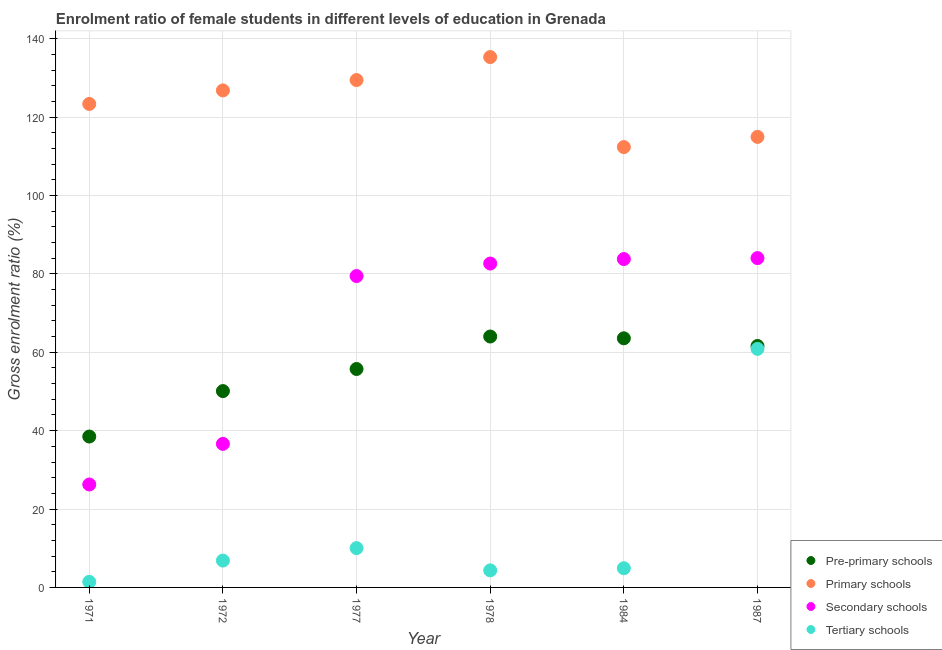Is the number of dotlines equal to the number of legend labels?
Provide a succinct answer. Yes. What is the gross enrolment ratio(male) in tertiary schools in 1972?
Ensure brevity in your answer.  6.85. Across all years, what is the maximum gross enrolment ratio(male) in primary schools?
Offer a terse response. 135.32. Across all years, what is the minimum gross enrolment ratio(male) in primary schools?
Provide a short and direct response. 112.36. In which year was the gross enrolment ratio(male) in pre-primary schools maximum?
Give a very brief answer. 1978. What is the total gross enrolment ratio(male) in secondary schools in the graph?
Ensure brevity in your answer.  392.79. What is the difference between the gross enrolment ratio(male) in pre-primary schools in 1971 and that in 1977?
Ensure brevity in your answer.  -17.23. What is the difference between the gross enrolment ratio(male) in pre-primary schools in 1972 and the gross enrolment ratio(male) in tertiary schools in 1978?
Give a very brief answer. 45.75. What is the average gross enrolment ratio(male) in secondary schools per year?
Provide a short and direct response. 65.46. In the year 1977, what is the difference between the gross enrolment ratio(male) in pre-primary schools and gross enrolment ratio(male) in tertiary schools?
Your answer should be very brief. 45.7. What is the ratio of the gross enrolment ratio(male) in secondary schools in 1978 to that in 1984?
Your answer should be very brief. 0.99. Is the gross enrolment ratio(male) in secondary schools in 1977 less than that in 1978?
Provide a succinct answer. Yes. Is the difference between the gross enrolment ratio(male) in tertiary schools in 1978 and 1984 greater than the difference between the gross enrolment ratio(male) in pre-primary schools in 1978 and 1984?
Keep it short and to the point. No. What is the difference between the highest and the second highest gross enrolment ratio(male) in primary schools?
Your answer should be very brief. 5.87. What is the difference between the highest and the lowest gross enrolment ratio(male) in tertiary schools?
Make the answer very short. 59.44. Is it the case that in every year, the sum of the gross enrolment ratio(male) in secondary schools and gross enrolment ratio(male) in tertiary schools is greater than the sum of gross enrolment ratio(male) in pre-primary schools and gross enrolment ratio(male) in primary schools?
Your answer should be compact. No. Does the gross enrolment ratio(male) in tertiary schools monotonically increase over the years?
Provide a short and direct response. No. Is the gross enrolment ratio(male) in secondary schools strictly greater than the gross enrolment ratio(male) in primary schools over the years?
Ensure brevity in your answer.  No. Does the graph contain any zero values?
Offer a very short reply. No. Where does the legend appear in the graph?
Your answer should be very brief. Bottom right. How are the legend labels stacked?
Provide a succinct answer. Vertical. What is the title of the graph?
Offer a very short reply. Enrolment ratio of female students in different levels of education in Grenada. What is the label or title of the Y-axis?
Keep it short and to the point. Gross enrolment ratio (%). What is the Gross enrolment ratio (%) in Pre-primary schools in 1971?
Offer a terse response. 38.5. What is the Gross enrolment ratio (%) in Primary schools in 1971?
Make the answer very short. 123.36. What is the Gross enrolment ratio (%) in Secondary schools in 1971?
Make the answer very short. 26.27. What is the Gross enrolment ratio (%) in Tertiary schools in 1971?
Give a very brief answer. 1.42. What is the Gross enrolment ratio (%) of Pre-primary schools in 1972?
Provide a succinct answer. 50.09. What is the Gross enrolment ratio (%) in Primary schools in 1972?
Your answer should be compact. 126.81. What is the Gross enrolment ratio (%) of Secondary schools in 1972?
Provide a short and direct response. 36.63. What is the Gross enrolment ratio (%) of Tertiary schools in 1972?
Your answer should be compact. 6.85. What is the Gross enrolment ratio (%) of Pre-primary schools in 1977?
Your answer should be compact. 55.73. What is the Gross enrolment ratio (%) in Primary schools in 1977?
Make the answer very short. 129.45. What is the Gross enrolment ratio (%) of Secondary schools in 1977?
Your response must be concise. 79.45. What is the Gross enrolment ratio (%) in Tertiary schools in 1977?
Your response must be concise. 10.03. What is the Gross enrolment ratio (%) in Pre-primary schools in 1978?
Your response must be concise. 64.02. What is the Gross enrolment ratio (%) in Primary schools in 1978?
Offer a terse response. 135.32. What is the Gross enrolment ratio (%) of Secondary schools in 1978?
Your answer should be compact. 82.64. What is the Gross enrolment ratio (%) of Tertiary schools in 1978?
Give a very brief answer. 4.35. What is the Gross enrolment ratio (%) in Pre-primary schools in 1984?
Ensure brevity in your answer.  63.56. What is the Gross enrolment ratio (%) of Primary schools in 1984?
Ensure brevity in your answer.  112.36. What is the Gross enrolment ratio (%) in Secondary schools in 1984?
Your response must be concise. 83.78. What is the Gross enrolment ratio (%) in Tertiary schools in 1984?
Provide a succinct answer. 4.89. What is the Gross enrolment ratio (%) in Pre-primary schools in 1987?
Offer a terse response. 61.6. What is the Gross enrolment ratio (%) in Primary schools in 1987?
Your answer should be compact. 114.95. What is the Gross enrolment ratio (%) of Secondary schools in 1987?
Provide a short and direct response. 84.03. What is the Gross enrolment ratio (%) of Tertiary schools in 1987?
Offer a very short reply. 60.86. Across all years, what is the maximum Gross enrolment ratio (%) in Pre-primary schools?
Provide a short and direct response. 64.02. Across all years, what is the maximum Gross enrolment ratio (%) of Primary schools?
Offer a very short reply. 135.32. Across all years, what is the maximum Gross enrolment ratio (%) of Secondary schools?
Offer a very short reply. 84.03. Across all years, what is the maximum Gross enrolment ratio (%) in Tertiary schools?
Your response must be concise. 60.86. Across all years, what is the minimum Gross enrolment ratio (%) in Pre-primary schools?
Your answer should be very brief. 38.5. Across all years, what is the minimum Gross enrolment ratio (%) of Primary schools?
Keep it short and to the point. 112.36. Across all years, what is the minimum Gross enrolment ratio (%) of Secondary schools?
Give a very brief answer. 26.27. Across all years, what is the minimum Gross enrolment ratio (%) of Tertiary schools?
Give a very brief answer. 1.42. What is the total Gross enrolment ratio (%) of Pre-primary schools in the graph?
Offer a very short reply. 333.51. What is the total Gross enrolment ratio (%) in Primary schools in the graph?
Give a very brief answer. 742.26. What is the total Gross enrolment ratio (%) in Secondary schools in the graph?
Keep it short and to the point. 392.79. What is the total Gross enrolment ratio (%) of Tertiary schools in the graph?
Your response must be concise. 88.42. What is the difference between the Gross enrolment ratio (%) of Pre-primary schools in 1971 and that in 1972?
Provide a short and direct response. -11.59. What is the difference between the Gross enrolment ratio (%) in Primary schools in 1971 and that in 1972?
Offer a terse response. -3.45. What is the difference between the Gross enrolment ratio (%) in Secondary schools in 1971 and that in 1972?
Offer a terse response. -10.36. What is the difference between the Gross enrolment ratio (%) of Tertiary schools in 1971 and that in 1972?
Provide a succinct answer. -5.43. What is the difference between the Gross enrolment ratio (%) in Pre-primary schools in 1971 and that in 1977?
Make the answer very short. -17.23. What is the difference between the Gross enrolment ratio (%) in Primary schools in 1971 and that in 1977?
Your response must be concise. -6.09. What is the difference between the Gross enrolment ratio (%) of Secondary schools in 1971 and that in 1977?
Provide a short and direct response. -53.18. What is the difference between the Gross enrolment ratio (%) in Tertiary schools in 1971 and that in 1977?
Ensure brevity in your answer.  -8.61. What is the difference between the Gross enrolment ratio (%) of Pre-primary schools in 1971 and that in 1978?
Ensure brevity in your answer.  -25.52. What is the difference between the Gross enrolment ratio (%) in Primary schools in 1971 and that in 1978?
Give a very brief answer. -11.96. What is the difference between the Gross enrolment ratio (%) of Secondary schools in 1971 and that in 1978?
Your answer should be very brief. -56.37. What is the difference between the Gross enrolment ratio (%) in Tertiary schools in 1971 and that in 1978?
Make the answer very short. -2.92. What is the difference between the Gross enrolment ratio (%) of Pre-primary schools in 1971 and that in 1984?
Keep it short and to the point. -25.06. What is the difference between the Gross enrolment ratio (%) in Primary schools in 1971 and that in 1984?
Ensure brevity in your answer.  11.01. What is the difference between the Gross enrolment ratio (%) in Secondary schools in 1971 and that in 1984?
Provide a succinct answer. -57.52. What is the difference between the Gross enrolment ratio (%) of Tertiary schools in 1971 and that in 1984?
Offer a terse response. -3.47. What is the difference between the Gross enrolment ratio (%) of Pre-primary schools in 1971 and that in 1987?
Your answer should be compact. -23.1. What is the difference between the Gross enrolment ratio (%) of Primary schools in 1971 and that in 1987?
Provide a short and direct response. 8.41. What is the difference between the Gross enrolment ratio (%) of Secondary schools in 1971 and that in 1987?
Ensure brevity in your answer.  -57.76. What is the difference between the Gross enrolment ratio (%) in Tertiary schools in 1971 and that in 1987?
Keep it short and to the point. -59.44. What is the difference between the Gross enrolment ratio (%) of Pre-primary schools in 1972 and that in 1977?
Ensure brevity in your answer.  -5.64. What is the difference between the Gross enrolment ratio (%) of Primary schools in 1972 and that in 1977?
Ensure brevity in your answer.  -2.64. What is the difference between the Gross enrolment ratio (%) of Secondary schools in 1972 and that in 1977?
Your response must be concise. -42.82. What is the difference between the Gross enrolment ratio (%) of Tertiary schools in 1972 and that in 1977?
Offer a very short reply. -3.18. What is the difference between the Gross enrolment ratio (%) in Pre-primary schools in 1972 and that in 1978?
Provide a short and direct response. -13.93. What is the difference between the Gross enrolment ratio (%) of Primary schools in 1972 and that in 1978?
Make the answer very short. -8.51. What is the difference between the Gross enrolment ratio (%) in Secondary schools in 1972 and that in 1978?
Your answer should be compact. -46.01. What is the difference between the Gross enrolment ratio (%) in Tertiary schools in 1972 and that in 1978?
Offer a very short reply. 2.51. What is the difference between the Gross enrolment ratio (%) of Pre-primary schools in 1972 and that in 1984?
Provide a succinct answer. -13.47. What is the difference between the Gross enrolment ratio (%) in Primary schools in 1972 and that in 1984?
Your answer should be compact. 14.46. What is the difference between the Gross enrolment ratio (%) in Secondary schools in 1972 and that in 1984?
Keep it short and to the point. -47.15. What is the difference between the Gross enrolment ratio (%) in Tertiary schools in 1972 and that in 1984?
Your response must be concise. 1.96. What is the difference between the Gross enrolment ratio (%) in Pre-primary schools in 1972 and that in 1987?
Your response must be concise. -11.51. What is the difference between the Gross enrolment ratio (%) in Primary schools in 1972 and that in 1987?
Your answer should be compact. 11.86. What is the difference between the Gross enrolment ratio (%) in Secondary schools in 1972 and that in 1987?
Provide a succinct answer. -47.4. What is the difference between the Gross enrolment ratio (%) in Tertiary schools in 1972 and that in 1987?
Your answer should be compact. -54.01. What is the difference between the Gross enrolment ratio (%) of Pre-primary schools in 1977 and that in 1978?
Offer a very short reply. -8.29. What is the difference between the Gross enrolment ratio (%) in Primary schools in 1977 and that in 1978?
Offer a very short reply. -5.87. What is the difference between the Gross enrolment ratio (%) of Secondary schools in 1977 and that in 1978?
Offer a very short reply. -3.19. What is the difference between the Gross enrolment ratio (%) in Tertiary schools in 1977 and that in 1978?
Your answer should be very brief. 5.69. What is the difference between the Gross enrolment ratio (%) in Pre-primary schools in 1977 and that in 1984?
Make the answer very short. -7.83. What is the difference between the Gross enrolment ratio (%) in Primary schools in 1977 and that in 1984?
Provide a short and direct response. 17.1. What is the difference between the Gross enrolment ratio (%) of Secondary schools in 1977 and that in 1984?
Offer a very short reply. -4.33. What is the difference between the Gross enrolment ratio (%) in Tertiary schools in 1977 and that in 1984?
Your answer should be very brief. 5.14. What is the difference between the Gross enrolment ratio (%) in Pre-primary schools in 1977 and that in 1987?
Offer a terse response. -5.87. What is the difference between the Gross enrolment ratio (%) in Primary schools in 1977 and that in 1987?
Your response must be concise. 14.5. What is the difference between the Gross enrolment ratio (%) in Secondary schools in 1977 and that in 1987?
Your answer should be very brief. -4.58. What is the difference between the Gross enrolment ratio (%) in Tertiary schools in 1977 and that in 1987?
Your response must be concise. -50.83. What is the difference between the Gross enrolment ratio (%) of Pre-primary schools in 1978 and that in 1984?
Ensure brevity in your answer.  0.46. What is the difference between the Gross enrolment ratio (%) of Primary schools in 1978 and that in 1984?
Offer a terse response. 22.96. What is the difference between the Gross enrolment ratio (%) in Secondary schools in 1978 and that in 1984?
Offer a very short reply. -1.14. What is the difference between the Gross enrolment ratio (%) in Tertiary schools in 1978 and that in 1984?
Your response must be concise. -0.55. What is the difference between the Gross enrolment ratio (%) in Pre-primary schools in 1978 and that in 1987?
Offer a very short reply. 2.42. What is the difference between the Gross enrolment ratio (%) in Primary schools in 1978 and that in 1987?
Keep it short and to the point. 20.37. What is the difference between the Gross enrolment ratio (%) in Secondary schools in 1978 and that in 1987?
Your answer should be very brief. -1.39. What is the difference between the Gross enrolment ratio (%) of Tertiary schools in 1978 and that in 1987?
Keep it short and to the point. -56.52. What is the difference between the Gross enrolment ratio (%) of Pre-primary schools in 1984 and that in 1987?
Offer a very short reply. 1.96. What is the difference between the Gross enrolment ratio (%) of Primary schools in 1984 and that in 1987?
Give a very brief answer. -2.6. What is the difference between the Gross enrolment ratio (%) of Secondary schools in 1984 and that in 1987?
Offer a terse response. -0.25. What is the difference between the Gross enrolment ratio (%) of Tertiary schools in 1984 and that in 1987?
Your response must be concise. -55.97. What is the difference between the Gross enrolment ratio (%) in Pre-primary schools in 1971 and the Gross enrolment ratio (%) in Primary schools in 1972?
Make the answer very short. -88.31. What is the difference between the Gross enrolment ratio (%) in Pre-primary schools in 1971 and the Gross enrolment ratio (%) in Secondary schools in 1972?
Make the answer very short. 1.87. What is the difference between the Gross enrolment ratio (%) of Pre-primary schools in 1971 and the Gross enrolment ratio (%) of Tertiary schools in 1972?
Offer a very short reply. 31.65. What is the difference between the Gross enrolment ratio (%) of Primary schools in 1971 and the Gross enrolment ratio (%) of Secondary schools in 1972?
Your answer should be compact. 86.74. What is the difference between the Gross enrolment ratio (%) in Primary schools in 1971 and the Gross enrolment ratio (%) in Tertiary schools in 1972?
Keep it short and to the point. 116.51. What is the difference between the Gross enrolment ratio (%) of Secondary schools in 1971 and the Gross enrolment ratio (%) of Tertiary schools in 1972?
Your response must be concise. 19.41. What is the difference between the Gross enrolment ratio (%) of Pre-primary schools in 1971 and the Gross enrolment ratio (%) of Primary schools in 1977?
Ensure brevity in your answer.  -90.95. What is the difference between the Gross enrolment ratio (%) of Pre-primary schools in 1971 and the Gross enrolment ratio (%) of Secondary schools in 1977?
Offer a terse response. -40.95. What is the difference between the Gross enrolment ratio (%) of Pre-primary schools in 1971 and the Gross enrolment ratio (%) of Tertiary schools in 1977?
Your answer should be compact. 28.47. What is the difference between the Gross enrolment ratio (%) of Primary schools in 1971 and the Gross enrolment ratio (%) of Secondary schools in 1977?
Offer a terse response. 43.92. What is the difference between the Gross enrolment ratio (%) of Primary schools in 1971 and the Gross enrolment ratio (%) of Tertiary schools in 1977?
Your answer should be compact. 113.33. What is the difference between the Gross enrolment ratio (%) of Secondary schools in 1971 and the Gross enrolment ratio (%) of Tertiary schools in 1977?
Keep it short and to the point. 16.23. What is the difference between the Gross enrolment ratio (%) in Pre-primary schools in 1971 and the Gross enrolment ratio (%) in Primary schools in 1978?
Give a very brief answer. -96.82. What is the difference between the Gross enrolment ratio (%) in Pre-primary schools in 1971 and the Gross enrolment ratio (%) in Secondary schools in 1978?
Offer a terse response. -44.14. What is the difference between the Gross enrolment ratio (%) in Pre-primary schools in 1971 and the Gross enrolment ratio (%) in Tertiary schools in 1978?
Provide a succinct answer. 34.15. What is the difference between the Gross enrolment ratio (%) of Primary schools in 1971 and the Gross enrolment ratio (%) of Secondary schools in 1978?
Provide a succinct answer. 40.73. What is the difference between the Gross enrolment ratio (%) of Primary schools in 1971 and the Gross enrolment ratio (%) of Tertiary schools in 1978?
Your response must be concise. 119.02. What is the difference between the Gross enrolment ratio (%) of Secondary schools in 1971 and the Gross enrolment ratio (%) of Tertiary schools in 1978?
Keep it short and to the point. 21.92. What is the difference between the Gross enrolment ratio (%) in Pre-primary schools in 1971 and the Gross enrolment ratio (%) in Primary schools in 1984?
Your answer should be very brief. -73.86. What is the difference between the Gross enrolment ratio (%) in Pre-primary schools in 1971 and the Gross enrolment ratio (%) in Secondary schools in 1984?
Give a very brief answer. -45.28. What is the difference between the Gross enrolment ratio (%) of Pre-primary schools in 1971 and the Gross enrolment ratio (%) of Tertiary schools in 1984?
Ensure brevity in your answer.  33.61. What is the difference between the Gross enrolment ratio (%) in Primary schools in 1971 and the Gross enrolment ratio (%) in Secondary schools in 1984?
Give a very brief answer. 39.58. What is the difference between the Gross enrolment ratio (%) of Primary schools in 1971 and the Gross enrolment ratio (%) of Tertiary schools in 1984?
Your answer should be compact. 118.47. What is the difference between the Gross enrolment ratio (%) of Secondary schools in 1971 and the Gross enrolment ratio (%) of Tertiary schools in 1984?
Your answer should be very brief. 21.37. What is the difference between the Gross enrolment ratio (%) of Pre-primary schools in 1971 and the Gross enrolment ratio (%) of Primary schools in 1987?
Your answer should be compact. -76.45. What is the difference between the Gross enrolment ratio (%) in Pre-primary schools in 1971 and the Gross enrolment ratio (%) in Secondary schools in 1987?
Your response must be concise. -45.53. What is the difference between the Gross enrolment ratio (%) in Pre-primary schools in 1971 and the Gross enrolment ratio (%) in Tertiary schools in 1987?
Your response must be concise. -22.36. What is the difference between the Gross enrolment ratio (%) in Primary schools in 1971 and the Gross enrolment ratio (%) in Secondary schools in 1987?
Keep it short and to the point. 39.34. What is the difference between the Gross enrolment ratio (%) of Primary schools in 1971 and the Gross enrolment ratio (%) of Tertiary schools in 1987?
Offer a terse response. 62.5. What is the difference between the Gross enrolment ratio (%) of Secondary schools in 1971 and the Gross enrolment ratio (%) of Tertiary schools in 1987?
Ensure brevity in your answer.  -34.6. What is the difference between the Gross enrolment ratio (%) of Pre-primary schools in 1972 and the Gross enrolment ratio (%) of Primary schools in 1977?
Your answer should be compact. -79.36. What is the difference between the Gross enrolment ratio (%) of Pre-primary schools in 1972 and the Gross enrolment ratio (%) of Secondary schools in 1977?
Your answer should be compact. -29.35. What is the difference between the Gross enrolment ratio (%) of Pre-primary schools in 1972 and the Gross enrolment ratio (%) of Tertiary schools in 1977?
Offer a very short reply. 40.06. What is the difference between the Gross enrolment ratio (%) of Primary schools in 1972 and the Gross enrolment ratio (%) of Secondary schools in 1977?
Your answer should be very brief. 47.36. What is the difference between the Gross enrolment ratio (%) in Primary schools in 1972 and the Gross enrolment ratio (%) in Tertiary schools in 1977?
Make the answer very short. 116.78. What is the difference between the Gross enrolment ratio (%) of Secondary schools in 1972 and the Gross enrolment ratio (%) of Tertiary schools in 1977?
Provide a short and direct response. 26.59. What is the difference between the Gross enrolment ratio (%) in Pre-primary schools in 1972 and the Gross enrolment ratio (%) in Primary schools in 1978?
Your response must be concise. -85.23. What is the difference between the Gross enrolment ratio (%) of Pre-primary schools in 1972 and the Gross enrolment ratio (%) of Secondary schools in 1978?
Provide a short and direct response. -32.54. What is the difference between the Gross enrolment ratio (%) in Pre-primary schools in 1972 and the Gross enrolment ratio (%) in Tertiary schools in 1978?
Ensure brevity in your answer.  45.75. What is the difference between the Gross enrolment ratio (%) of Primary schools in 1972 and the Gross enrolment ratio (%) of Secondary schools in 1978?
Provide a short and direct response. 44.17. What is the difference between the Gross enrolment ratio (%) of Primary schools in 1972 and the Gross enrolment ratio (%) of Tertiary schools in 1978?
Your response must be concise. 122.47. What is the difference between the Gross enrolment ratio (%) in Secondary schools in 1972 and the Gross enrolment ratio (%) in Tertiary schools in 1978?
Give a very brief answer. 32.28. What is the difference between the Gross enrolment ratio (%) of Pre-primary schools in 1972 and the Gross enrolment ratio (%) of Primary schools in 1984?
Offer a very short reply. -62.26. What is the difference between the Gross enrolment ratio (%) in Pre-primary schools in 1972 and the Gross enrolment ratio (%) in Secondary schools in 1984?
Provide a short and direct response. -33.69. What is the difference between the Gross enrolment ratio (%) of Pre-primary schools in 1972 and the Gross enrolment ratio (%) of Tertiary schools in 1984?
Provide a short and direct response. 45.2. What is the difference between the Gross enrolment ratio (%) of Primary schools in 1972 and the Gross enrolment ratio (%) of Secondary schools in 1984?
Your answer should be compact. 43.03. What is the difference between the Gross enrolment ratio (%) of Primary schools in 1972 and the Gross enrolment ratio (%) of Tertiary schools in 1984?
Give a very brief answer. 121.92. What is the difference between the Gross enrolment ratio (%) of Secondary schools in 1972 and the Gross enrolment ratio (%) of Tertiary schools in 1984?
Give a very brief answer. 31.73. What is the difference between the Gross enrolment ratio (%) of Pre-primary schools in 1972 and the Gross enrolment ratio (%) of Primary schools in 1987?
Make the answer very short. -64.86. What is the difference between the Gross enrolment ratio (%) of Pre-primary schools in 1972 and the Gross enrolment ratio (%) of Secondary schools in 1987?
Give a very brief answer. -33.93. What is the difference between the Gross enrolment ratio (%) of Pre-primary schools in 1972 and the Gross enrolment ratio (%) of Tertiary schools in 1987?
Make the answer very short. -10.77. What is the difference between the Gross enrolment ratio (%) in Primary schools in 1972 and the Gross enrolment ratio (%) in Secondary schools in 1987?
Keep it short and to the point. 42.79. What is the difference between the Gross enrolment ratio (%) of Primary schools in 1972 and the Gross enrolment ratio (%) of Tertiary schools in 1987?
Your answer should be compact. 65.95. What is the difference between the Gross enrolment ratio (%) of Secondary schools in 1972 and the Gross enrolment ratio (%) of Tertiary schools in 1987?
Keep it short and to the point. -24.24. What is the difference between the Gross enrolment ratio (%) of Pre-primary schools in 1977 and the Gross enrolment ratio (%) of Primary schools in 1978?
Your response must be concise. -79.59. What is the difference between the Gross enrolment ratio (%) in Pre-primary schools in 1977 and the Gross enrolment ratio (%) in Secondary schools in 1978?
Your answer should be compact. -26.91. What is the difference between the Gross enrolment ratio (%) in Pre-primary schools in 1977 and the Gross enrolment ratio (%) in Tertiary schools in 1978?
Your answer should be very brief. 51.39. What is the difference between the Gross enrolment ratio (%) in Primary schools in 1977 and the Gross enrolment ratio (%) in Secondary schools in 1978?
Keep it short and to the point. 46.82. What is the difference between the Gross enrolment ratio (%) in Primary schools in 1977 and the Gross enrolment ratio (%) in Tertiary schools in 1978?
Give a very brief answer. 125.11. What is the difference between the Gross enrolment ratio (%) in Secondary schools in 1977 and the Gross enrolment ratio (%) in Tertiary schools in 1978?
Provide a short and direct response. 75.1. What is the difference between the Gross enrolment ratio (%) of Pre-primary schools in 1977 and the Gross enrolment ratio (%) of Primary schools in 1984?
Ensure brevity in your answer.  -56.62. What is the difference between the Gross enrolment ratio (%) of Pre-primary schools in 1977 and the Gross enrolment ratio (%) of Secondary schools in 1984?
Make the answer very short. -28.05. What is the difference between the Gross enrolment ratio (%) of Pre-primary schools in 1977 and the Gross enrolment ratio (%) of Tertiary schools in 1984?
Offer a very short reply. 50.84. What is the difference between the Gross enrolment ratio (%) of Primary schools in 1977 and the Gross enrolment ratio (%) of Secondary schools in 1984?
Provide a succinct answer. 45.67. What is the difference between the Gross enrolment ratio (%) in Primary schools in 1977 and the Gross enrolment ratio (%) in Tertiary schools in 1984?
Provide a succinct answer. 124.56. What is the difference between the Gross enrolment ratio (%) in Secondary schools in 1977 and the Gross enrolment ratio (%) in Tertiary schools in 1984?
Make the answer very short. 74.55. What is the difference between the Gross enrolment ratio (%) in Pre-primary schools in 1977 and the Gross enrolment ratio (%) in Primary schools in 1987?
Your response must be concise. -59.22. What is the difference between the Gross enrolment ratio (%) of Pre-primary schools in 1977 and the Gross enrolment ratio (%) of Secondary schools in 1987?
Provide a short and direct response. -28.29. What is the difference between the Gross enrolment ratio (%) of Pre-primary schools in 1977 and the Gross enrolment ratio (%) of Tertiary schools in 1987?
Keep it short and to the point. -5.13. What is the difference between the Gross enrolment ratio (%) in Primary schools in 1977 and the Gross enrolment ratio (%) in Secondary schools in 1987?
Make the answer very short. 45.43. What is the difference between the Gross enrolment ratio (%) of Primary schools in 1977 and the Gross enrolment ratio (%) of Tertiary schools in 1987?
Provide a short and direct response. 68.59. What is the difference between the Gross enrolment ratio (%) of Secondary schools in 1977 and the Gross enrolment ratio (%) of Tertiary schools in 1987?
Your response must be concise. 18.58. What is the difference between the Gross enrolment ratio (%) of Pre-primary schools in 1978 and the Gross enrolment ratio (%) of Primary schools in 1984?
Ensure brevity in your answer.  -48.34. What is the difference between the Gross enrolment ratio (%) in Pre-primary schools in 1978 and the Gross enrolment ratio (%) in Secondary schools in 1984?
Give a very brief answer. -19.76. What is the difference between the Gross enrolment ratio (%) of Pre-primary schools in 1978 and the Gross enrolment ratio (%) of Tertiary schools in 1984?
Make the answer very short. 59.13. What is the difference between the Gross enrolment ratio (%) in Primary schools in 1978 and the Gross enrolment ratio (%) in Secondary schools in 1984?
Give a very brief answer. 51.54. What is the difference between the Gross enrolment ratio (%) in Primary schools in 1978 and the Gross enrolment ratio (%) in Tertiary schools in 1984?
Provide a short and direct response. 130.43. What is the difference between the Gross enrolment ratio (%) in Secondary schools in 1978 and the Gross enrolment ratio (%) in Tertiary schools in 1984?
Offer a terse response. 77.75. What is the difference between the Gross enrolment ratio (%) in Pre-primary schools in 1978 and the Gross enrolment ratio (%) in Primary schools in 1987?
Offer a very short reply. -50.93. What is the difference between the Gross enrolment ratio (%) of Pre-primary schools in 1978 and the Gross enrolment ratio (%) of Secondary schools in 1987?
Keep it short and to the point. -20.01. What is the difference between the Gross enrolment ratio (%) in Pre-primary schools in 1978 and the Gross enrolment ratio (%) in Tertiary schools in 1987?
Provide a short and direct response. 3.16. What is the difference between the Gross enrolment ratio (%) in Primary schools in 1978 and the Gross enrolment ratio (%) in Secondary schools in 1987?
Your response must be concise. 51.29. What is the difference between the Gross enrolment ratio (%) of Primary schools in 1978 and the Gross enrolment ratio (%) of Tertiary schools in 1987?
Your answer should be very brief. 74.46. What is the difference between the Gross enrolment ratio (%) in Secondary schools in 1978 and the Gross enrolment ratio (%) in Tertiary schools in 1987?
Your answer should be compact. 21.77. What is the difference between the Gross enrolment ratio (%) in Pre-primary schools in 1984 and the Gross enrolment ratio (%) in Primary schools in 1987?
Offer a terse response. -51.39. What is the difference between the Gross enrolment ratio (%) in Pre-primary schools in 1984 and the Gross enrolment ratio (%) in Secondary schools in 1987?
Provide a short and direct response. -20.46. What is the difference between the Gross enrolment ratio (%) of Pre-primary schools in 1984 and the Gross enrolment ratio (%) of Tertiary schools in 1987?
Your answer should be compact. 2.7. What is the difference between the Gross enrolment ratio (%) in Primary schools in 1984 and the Gross enrolment ratio (%) in Secondary schools in 1987?
Offer a terse response. 28.33. What is the difference between the Gross enrolment ratio (%) of Primary schools in 1984 and the Gross enrolment ratio (%) of Tertiary schools in 1987?
Provide a succinct answer. 51.49. What is the difference between the Gross enrolment ratio (%) in Secondary schools in 1984 and the Gross enrolment ratio (%) in Tertiary schools in 1987?
Offer a very short reply. 22.92. What is the average Gross enrolment ratio (%) of Pre-primary schools per year?
Your response must be concise. 55.59. What is the average Gross enrolment ratio (%) in Primary schools per year?
Provide a short and direct response. 123.71. What is the average Gross enrolment ratio (%) in Secondary schools per year?
Ensure brevity in your answer.  65.46. What is the average Gross enrolment ratio (%) of Tertiary schools per year?
Your response must be concise. 14.74. In the year 1971, what is the difference between the Gross enrolment ratio (%) of Pre-primary schools and Gross enrolment ratio (%) of Primary schools?
Your response must be concise. -84.86. In the year 1971, what is the difference between the Gross enrolment ratio (%) of Pre-primary schools and Gross enrolment ratio (%) of Secondary schools?
Your answer should be very brief. 12.24. In the year 1971, what is the difference between the Gross enrolment ratio (%) in Pre-primary schools and Gross enrolment ratio (%) in Tertiary schools?
Provide a short and direct response. 37.08. In the year 1971, what is the difference between the Gross enrolment ratio (%) of Primary schools and Gross enrolment ratio (%) of Secondary schools?
Offer a very short reply. 97.1. In the year 1971, what is the difference between the Gross enrolment ratio (%) in Primary schools and Gross enrolment ratio (%) in Tertiary schools?
Your response must be concise. 121.94. In the year 1971, what is the difference between the Gross enrolment ratio (%) of Secondary schools and Gross enrolment ratio (%) of Tertiary schools?
Make the answer very short. 24.84. In the year 1972, what is the difference between the Gross enrolment ratio (%) of Pre-primary schools and Gross enrolment ratio (%) of Primary schools?
Offer a very short reply. -76.72. In the year 1972, what is the difference between the Gross enrolment ratio (%) in Pre-primary schools and Gross enrolment ratio (%) in Secondary schools?
Your answer should be compact. 13.47. In the year 1972, what is the difference between the Gross enrolment ratio (%) in Pre-primary schools and Gross enrolment ratio (%) in Tertiary schools?
Provide a succinct answer. 43.24. In the year 1972, what is the difference between the Gross enrolment ratio (%) in Primary schools and Gross enrolment ratio (%) in Secondary schools?
Provide a succinct answer. 90.19. In the year 1972, what is the difference between the Gross enrolment ratio (%) of Primary schools and Gross enrolment ratio (%) of Tertiary schools?
Give a very brief answer. 119.96. In the year 1972, what is the difference between the Gross enrolment ratio (%) in Secondary schools and Gross enrolment ratio (%) in Tertiary schools?
Provide a succinct answer. 29.77. In the year 1977, what is the difference between the Gross enrolment ratio (%) in Pre-primary schools and Gross enrolment ratio (%) in Primary schools?
Your response must be concise. -73.72. In the year 1977, what is the difference between the Gross enrolment ratio (%) in Pre-primary schools and Gross enrolment ratio (%) in Secondary schools?
Your response must be concise. -23.72. In the year 1977, what is the difference between the Gross enrolment ratio (%) in Pre-primary schools and Gross enrolment ratio (%) in Tertiary schools?
Offer a terse response. 45.7. In the year 1977, what is the difference between the Gross enrolment ratio (%) in Primary schools and Gross enrolment ratio (%) in Secondary schools?
Your answer should be very brief. 50.01. In the year 1977, what is the difference between the Gross enrolment ratio (%) in Primary schools and Gross enrolment ratio (%) in Tertiary schools?
Your answer should be very brief. 119.42. In the year 1977, what is the difference between the Gross enrolment ratio (%) in Secondary schools and Gross enrolment ratio (%) in Tertiary schools?
Make the answer very short. 69.41. In the year 1978, what is the difference between the Gross enrolment ratio (%) in Pre-primary schools and Gross enrolment ratio (%) in Primary schools?
Your answer should be compact. -71.3. In the year 1978, what is the difference between the Gross enrolment ratio (%) in Pre-primary schools and Gross enrolment ratio (%) in Secondary schools?
Offer a terse response. -18.62. In the year 1978, what is the difference between the Gross enrolment ratio (%) in Pre-primary schools and Gross enrolment ratio (%) in Tertiary schools?
Your answer should be very brief. 59.67. In the year 1978, what is the difference between the Gross enrolment ratio (%) of Primary schools and Gross enrolment ratio (%) of Secondary schools?
Ensure brevity in your answer.  52.68. In the year 1978, what is the difference between the Gross enrolment ratio (%) in Primary schools and Gross enrolment ratio (%) in Tertiary schools?
Your answer should be very brief. 130.97. In the year 1978, what is the difference between the Gross enrolment ratio (%) in Secondary schools and Gross enrolment ratio (%) in Tertiary schools?
Keep it short and to the point. 78.29. In the year 1984, what is the difference between the Gross enrolment ratio (%) in Pre-primary schools and Gross enrolment ratio (%) in Primary schools?
Your answer should be compact. -48.79. In the year 1984, what is the difference between the Gross enrolment ratio (%) in Pre-primary schools and Gross enrolment ratio (%) in Secondary schools?
Your response must be concise. -20.22. In the year 1984, what is the difference between the Gross enrolment ratio (%) of Pre-primary schools and Gross enrolment ratio (%) of Tertiary schools?
Your response must be concise. 58.67. In the year 1984, what is the difference between the Gross enrolment ratio (%) in Primary schools and Gross enrolment ratio (%) in Secondary schools?
Offer a very short reply. 28.57. In the year 1984, what is the difference between the Gross enrolment ratio (%) in Primary schools and Gross enrolment ratio (%) in Tertiary schools?
Give a very brief answer. 107.46. In the year 1984, what is the difference between the Gross enrolment ratio (%) in Secondary schools and Gross enrolment ratio (%) in Tertiary schools?
Your answer should be very brief. 78.89. In the year 1987, what is the difference between the Gross enrolment ratio (%) in Pre-primary schools and Gross enrolment ratio (%) in Primary schools?
Make the answer very short. -53.35. In the year 1987, what is the difference between the Gross enrolment ratio (%) in Pre-primary schools and Gross enrolment ratio (%) in Secondary schools?
Provide a succinct answer. -22.43. In the year 1987, what is the difference between the Gross enrolment ratio (%) of Pre-primary schools and Gross enrolment ratio (%) of Tertiary schools?
Keep it short and to the point. 0.74. In the year 1987, what is the difference between the Gross enrolment ratio (%) of Primary schools and Gross enrolment ratio (%) of Secondary schools?
Your response must be concise. 30.93. In the year 1987, what is the difference between the Gross enrolment ratio (%) of Primary schools and Gross enrolment ratio (%) of Tertiary schools?
Offer a terse response. 54.09. In the year 1987, what is the difference between the Gross enrolment ratio (%) in Secondary schools and Gross enrolment ratio (%) in Tertiary schools?
Offer a very short reply. 23.16. What is the ratio of the Gross enrolment ratio (%) of Pre-primary schools in 1971 to that in 1972?
Keep it short and to the point. 0.77. What is the ratio of the Gross enrolment ratio (%) in Primary schools in 1971 to that in 1972?
Offer a terse response. 0.97. What is the ratio of the Gross enrolment ratio (%) in Secondary schools in 1971 to that in 1972?
Make the answer very short. 0.72. What is the ratio of the Gross enrolment ratio (%) in Tertiary schools in 1971 to that in 1972?
Provide a succinct answer. 0.21. What is the ratio of the Gross enrolment ratio (%) of Pre-primary schools in 1971 to that in 1977?
Give a very brief answer. 0.69. What is the ratio of the Gross enrolment ratio (%) of Primary schools in 1971 to that in 1977?
Keep it short and to the point. 0.95. What is the ratio of the Gross enrolment ratio (%) of Secondary schools in 1971 to that in 1977?
Give a very brief answer. 0.33. What is the ratio of the Gross enrolment ratio (%) in Tertiary schools in 1971 to that in 1977?
Give a very brief answer. 0.14. What is the ratio of the Gross enrolment ratio (%) of Pre-primary schools in 1971 to that in 1978?
Your answer should be very brief. 0.6. What is the ratio of the Gross enrolment ratio (%) of Primary schools in 1971 to that in 1978?
Offer a very short reply. 0.91. What is the ratio of the Gross enrolment ratio (%) in Secondary schools in 1971 to that in 1978?
Give a very brief answer. 0.32. What is the ratio of the Gross enrolment ratio (%) of Tertiary schools in 1971 to that in 1978?
Ensure brevity in your answer.  0.33. What is the ratio of the Gross enrolment ratio (%) in Pre-primary schools in 1971 to that in 1984?
Give a very brief answer. 0.61. What is the ratio of the Gross enrolment ratio (%) in Primary schools in 1971 to that in 1984?
Ensure brevity in your answer.  1.1. What is the ratio of the Gross enrolment ratio (%) in Secondary schools in 1971 to that in 1984?
Your response must be concise. 0.31. What is the ratio of the Gross enrolment ratio (%) in Tertiary schools in 1971 to that in 1984?
Give a very brief answer. 0.29. What is the ratio of the Gross enrolment ratio (%) of Primary schools in 1971 to that in 1987?
Your answer should be compact. 1.07. What is the ratio of the Gross enrolment ratio (%) of Secondary schools in 1971 to that in 1987?
Make the answer very short. 0.31. What is the ratio of the Gross enrolment ratio (%) in Tertiary schools in 1971 to that in 1987?
Your answer should be compact. 0.02. What is the ratio of the Gross enrolment ratio (%) of Pre-primary schools in 1972 to that in 1977?
Your answer should be compact. 0.9. What is the ratio of the Gross enrolment ratio (%) of Primary schools in 1972 to that in 1977?
Keep it short and to the point. 0.98. What is the ratio of the Gross enrolment ratio (%) of Secondary schools in 1972 to that in 1977?
Your answer should be compact. 0.46. What is the ratio of the Gross enrolment ratio (%) in Tertiary schools in 1972 to that in 1977?
Your answer should be compact. 0.68. What is the ratio of the Gross enrolment ratio (%) of Pre-primary schools in 1972 to that in 1978?
Keep it short and to the point. 0.78. What is the ratio of the Gross enrolment ratio (%) in Primary schools in 1972 to that in 1978?
Make the answer very short. 0.94. What is the ratio of the Gross enrolment ratio (%) of Secondary schools in 1972 to that in 1978?
Offer a very short reply. 0.44. What is the ratio of the Gross enrolment ratio (%) in Tertiary schools in 1972 to that in 1978?
Your answer should be very brief. 1.58. What is the ratio of the Gross enrolment ratio (%) of Pre-primary schools in 1972 to that in 1984?
Provide a short and direct response. 0.79. What is the ratio of the Gross enrolment ratio (%) of Primary schools in 1972 to that in 1984?
Offer a very short reply. 1.13. What is the ratio of the Gross enrolment ratio (%) in Secondary schools in 1972 to that in 1984?
Keep it short and to the point. 0.44. What is the ratio of the Gross enrolment ratio (%) in Tertiary schools in 1972 to that in 1984?
Offer a very short reply. 1.4. What is the ratio of the Gross enrolment ratio (%) of Pre-primary schools in 1972 to that in 1987?
Your response must be concise. 0.81. What is the ratio of the Gross enrolment ratio (%) of Primary schools in 1972 to that in 1987?
Your answer should be compact. 1.1. What is the ratio of the Gross enrolment ratio (%) in Secondary schools in 1972 to that in 1987?
Your response must be concise. 0.44. What is the ratio of the Gross enrolment ratio (%) of Tertiary schools in 1972 to that in 1987?
Provide a succinct answer. 0.11. What is the ratio of the Gross enrolment ratio (%) of Pre-primary schools in 1977 to that in 1978?
Give a very brief answer. 0.87. What is the ratio of the Gross enrolment ratio (%) of Primary schools in 1977 to that in 1978?
Ensure brevity in your answer.  0.96. What is the ratio of the Gross enrolment ratio (%) in Secondary schools in 1977 to that in 1978?
Your answer should be compact. 0.96. What is the ratio of the Gross enrolment ratio (%) in Tertiary schools in 1977 to that in 1978?
Give a very brief answer. 2.31. What is the ratio of the Gross enrolment ratio (%) of Pre-primary schools in 1977 to that in 1984?
Ensure brevity in your answer.  0.88. What is the ratio of the Gross enrolment ratio (%) of Primary schools in 1977 to that in 1984?
Ensure brevity in your answer.  1.15. What is the ratio of the Gross enrolment ratio (%) of Secondary schools in 1977 to that in 1984?
Provide a short and direct response. 0.95. What is the ratio of the Gross enrolment ratio (%) in Tertiary schools in 1977 to that in 1984?
Give a very brief answer. 2.05. What is the ratio of the Gross enrolment ratio (%) in Pre-primary schools in 1977 to that in 1987?
Your response must be concise. 0.9. What is the ratio of the Gross enrolment ratio (%) of Primary schools in 1977 to that in 1987?
Offer a very short reply. 1.13. What is the ratio of the Gross enrolment ratio (%) of Secondary schools in 1977 to that in 1987?
Provide a short and direct response. 0.95. What is the ratio of the Gross enrolment ratio (%) of Tertiary schools in 1977 to that in 1987?
Your response must be concise. 0.16. What is the ratio of the Gross enrolment ratio (%) of Pre-primary schools in 1978 to that in 1984?
Provide a succinct answer. 1.01. What is the ratio of the Gross enrolment ratio (%) of Primary schools in 1978 to that in 1984?
Give a very brief answer. 1.2. What is the ratio of the Gross enrolment ratio (%) of Secondary schools in 1978 to that in 1984?
Keep it short and to the point. 0.99. What is the ratio of the Gross enrolment ratio (%) of Tertiary schools in 1978 to that in 1984?
Your answer should be compact. 0.89. What is the ratio of the Gross enrolment ratio (%) of Pre-primary schools in 1978 to that in 1987?
Ensure brevity in your answer.  1.04. What is the ratio of the Gross enrolment ratio (%) in Primary schools in 1978 to that in 1987?
Offer a terse response. 1.18. What is the ratio of the Gross enrolment ratio (%) of Secondary schools in 1978 to that in 1987?
Keep it short and to the point. 0.98. What is the ratio of the Gross enrolment ratio (%) in Tertiary schools in 1978 to that in 1987?
Keep it short and to the point. 0.07. What is the ratio of the Gross enrolment ratio (%) of Pre-primary schools in 1984 to that in 1987?
Ensure brevity in your answer.  1.03. What is the ratio of the Gross enrolment ratio (%) of Primary schools in 1984 to that in 1987?
Your response must be concise. 0.98. What is the ratio of the Gross enrolment ratio (%) in Secondary schools in 1984 to that in 1987?
Keep it short and to the point. 1. What is the ratio of the Gross enrolment ratio (%) in Tertiary schools in 1984 to that in 1987?
Your response must be concise. 0.08. What is the difference between the highest and the second highest Gross enrolment ratio (%) of Pre-primary schools?
Make the answer very short. 0.46. What is the difference between the highest and the second highest Gross enrolment ratio (%) in Primary schools?
Make the answer very short. 5.87. What is the difference between the highest and the second highest Gross enrolment ratio (%) of Secondary schools?
Keep it short and to the point. 0.25. What is the difference between the highest and the second highest Gross enrolment ratio (%) of Tertiary schools?
Make the answer very short. 50.83. What is the difference between the highest and the lowest Gross enrolment ratio (%) in Pre-primary schools?
Make the answer very short. 25.52. What is the difference between the highest and the lowest Gross enrolment ratio (%) in Primary schools?
Your response must be concise. 22.96. What is the difference between the highest and the lowest Gross enrolment ratio (%) of Secondary schools?
Your answer should be very brief. 57.76. What is the difference between the highest and the lowest Gross enrolment ratio (%) in Tertiary schools?
Give a very brief answer. 59.44. 